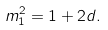Convert formula to latex. <formula><loc_0><loc_0><loc_500><loc_500>m _ { 1 } ^ { 2 } = 1 + 2 d .</formula> 